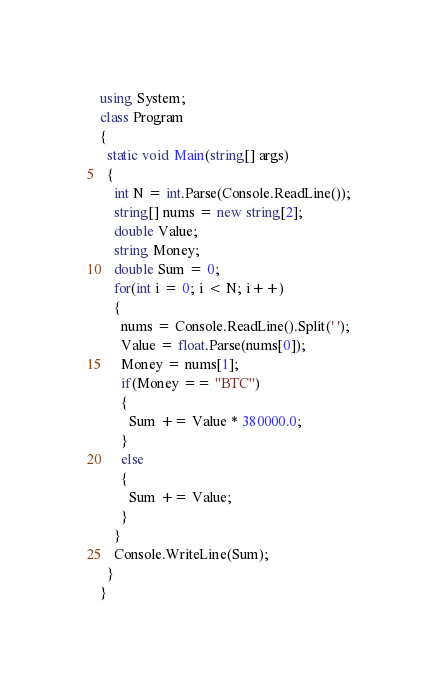<code> <loc_0><loc_0><loc_500><loc_500><_C#_>using System;
class Program
{
  static void Main(string[] args)
  {
    int N = int.Parse(Console.ReadLine());
    string[] nums = new string[2];
    double Value;
    string Money;
    double Sum = 0;
    for(int i = 0; i < N; i++)
    {
      nums = Console.ReadLine().Split(' ');
      Value = float.Parse(nums[0]);
      Money = nums[1];
      if(Money == "BTC")
      {
        Sum += Value * 380000.0;
      }
      else
      {
        Sum += Value;
      }
    }
    Console.WriteLine(Sum);
  }
}</code> 